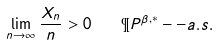Convert formula to latex. <formula><loc_0><loc_0><loc_500><loc_500>\lim _ { n \to \infty } \frac { X _ { n } } { n } > 0 \quad \P P ^ { \beta , * } - - a . s .</formula> 